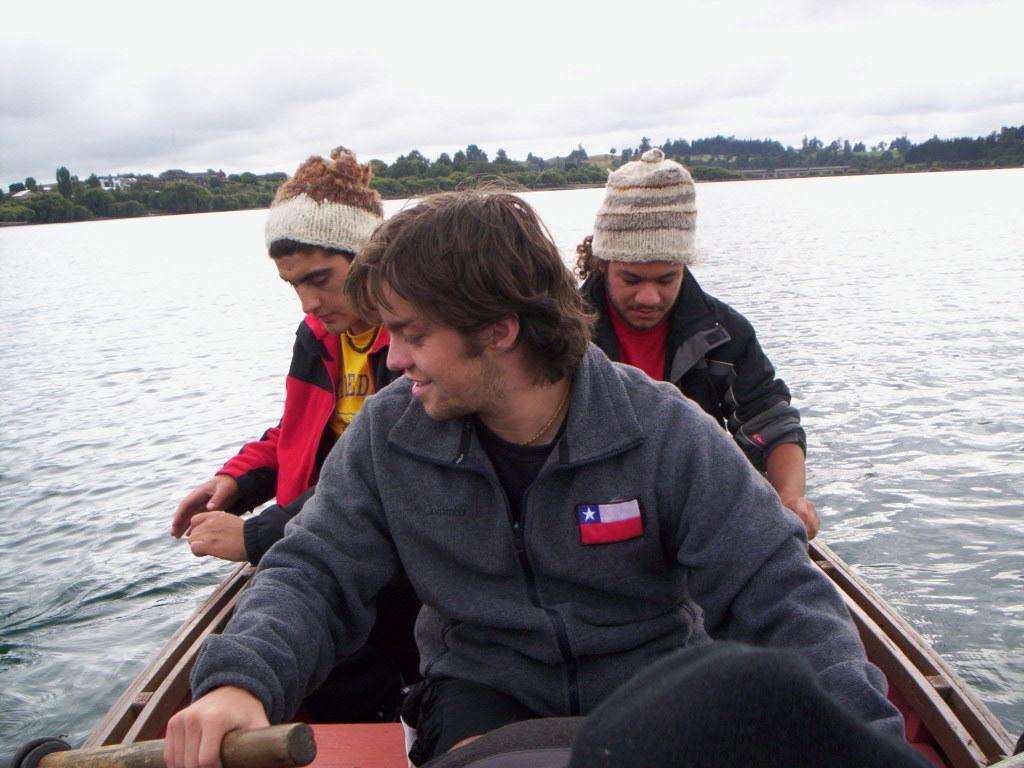How would you summarize this image in a sentence or two? In this image we can see three persons sitting in a boat and we can also see water, trees and sky. 